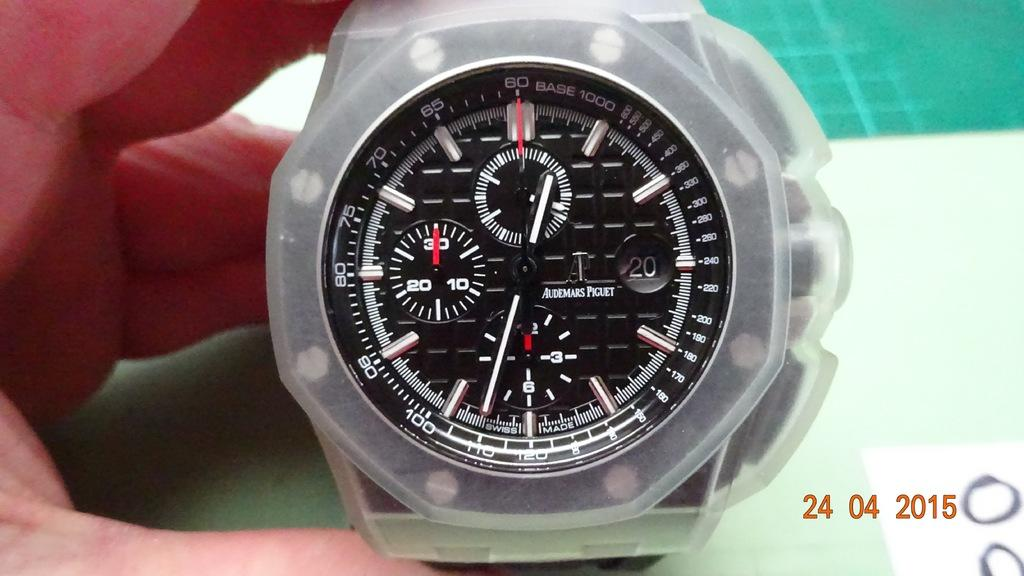<image>
Render a clear and concise summary of the photo. Audemars Piguet men's watch in plastic case with Base 1000. 